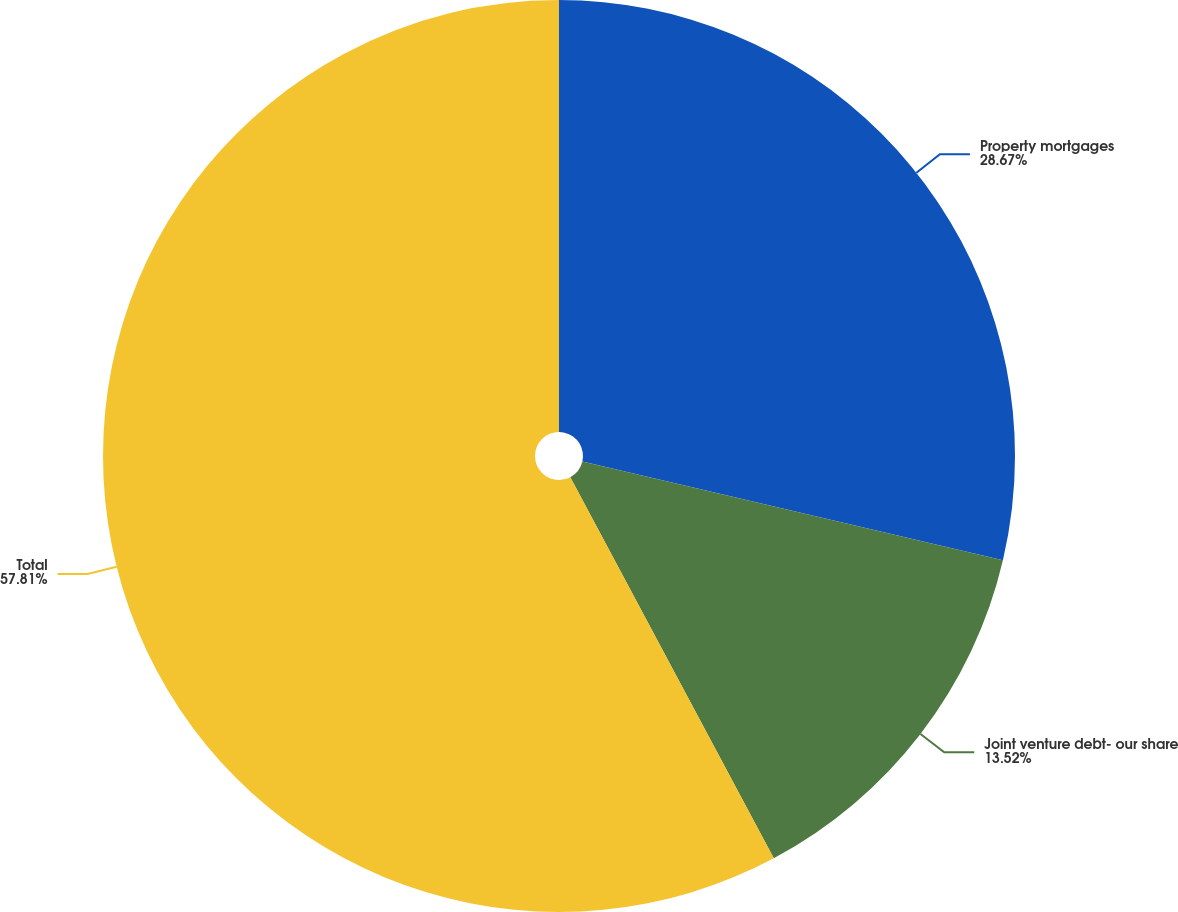Convert chart to OTSL. <chart><loc_0><loc_0><loc_500><loc_500><pie_chart><fcel>Property mortgages<fcel>Joint venture debt- our share<fcel>Total<nl><fcel>28.67%<fcel>13.52%<fcel>57.8%<nl></chart> 